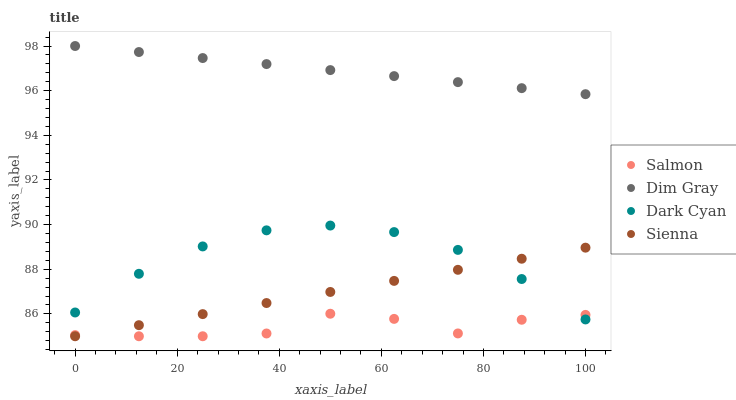Does Salmon have the minimum area under the curve?
Answer yes or no. Yes. Does Dim Gray have the maximum area under the curve?
Answer yes or no. Yes. Does Sienna have the minimum area under the curve?
Answer yes or no. No. Does Sienna have the maximum area under the curve?
Answer yes or no. No. Is Dim Gray the smoothest?
Answer yes or no. Yes. Is Salmon the roughest?
Answer yes or no. Yes. Is Sienna the smoothest?
Answer yes or no. No. Is Sienna the roughest?
Answer yes or no. No. Does Sienna have the lowest value?
Answer yes or no. Yes. Does Dim Gray have the lowest value?
Answer yes or no. No. Does Dim Gray have the highest value?
Answer yes or no. Yes. Does Sienna have the highest value?
Answer yes or no. No. Is Sienna less than Dim Gray?
Answer yes or no. Yes. Is Dim Gray greater than Dark Cyan?
Answer yes or no. Yes. Does Sienna intersect Dark Cyan?
Answer yes or no. Yes. Is Sienna less than Dark Cyan?
Answer yes or no. No. Is Sienna greater than Dark Cyan?
Answer yes or no. No. Does Sienna intersect Dim Gray?
Answer yes or no. No. 